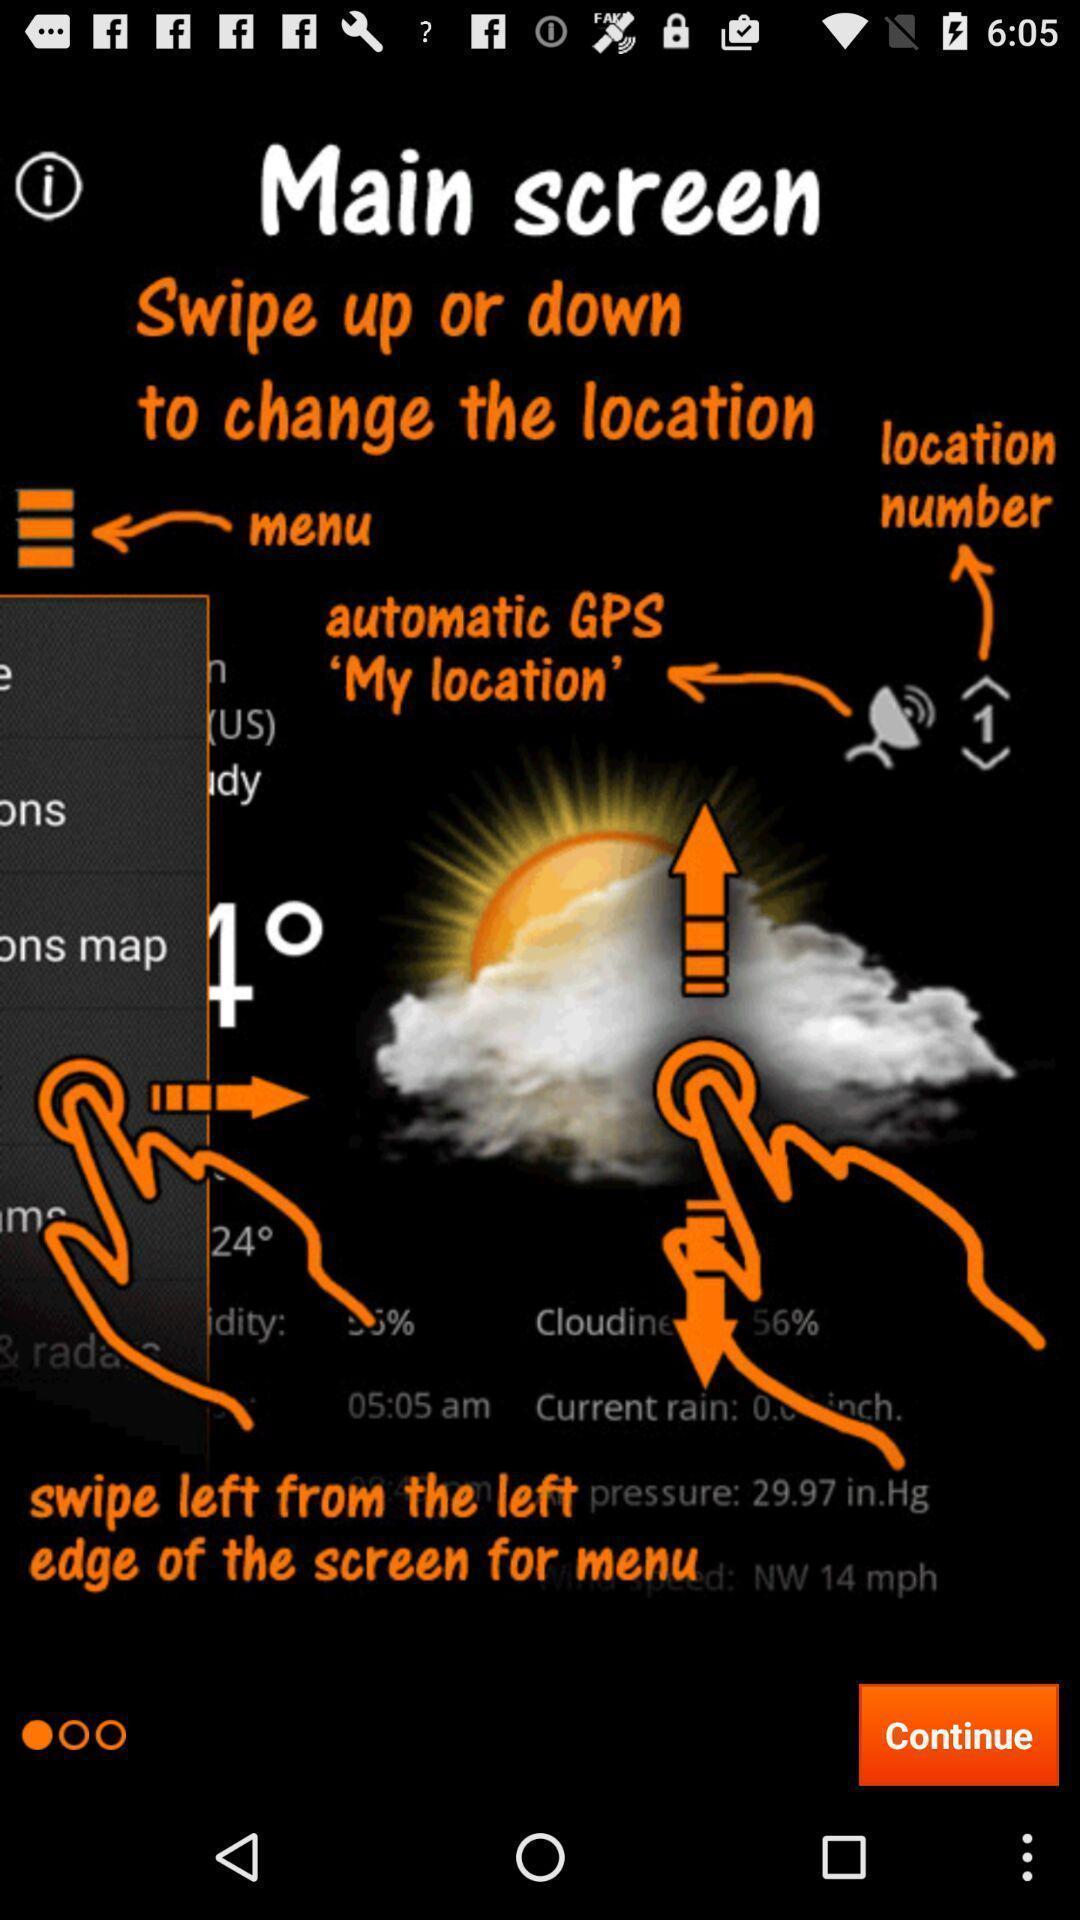Give me a narrative description of this picture. Various features displayed on the main screen. 